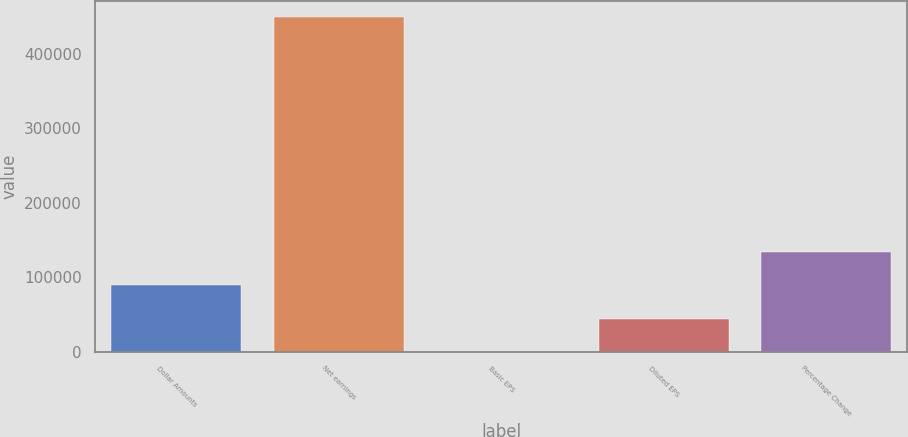Convert chart to OTSL. <chart><loc_0><loc_0><loc_500><loc_500><bar_chart><fcel>Dollar Amounts<fcel>Net earnings<fcel>Basic EPS<fcel>Diluted EPS<fcel>Percentage Change<nl><fcel>89728.4<fcel>448636<fcel>1.51<fcel>44865<fcel>134592<nl></chart> 